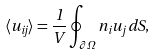<formula> <loc_0><loc_0><loc_500><loc_500>\langle u _ { i j } \rangle = \frac { 1 } { V } \oint _ { \partial \varOmega } n _ { i } u _ { j } \, d S ,</formula> 